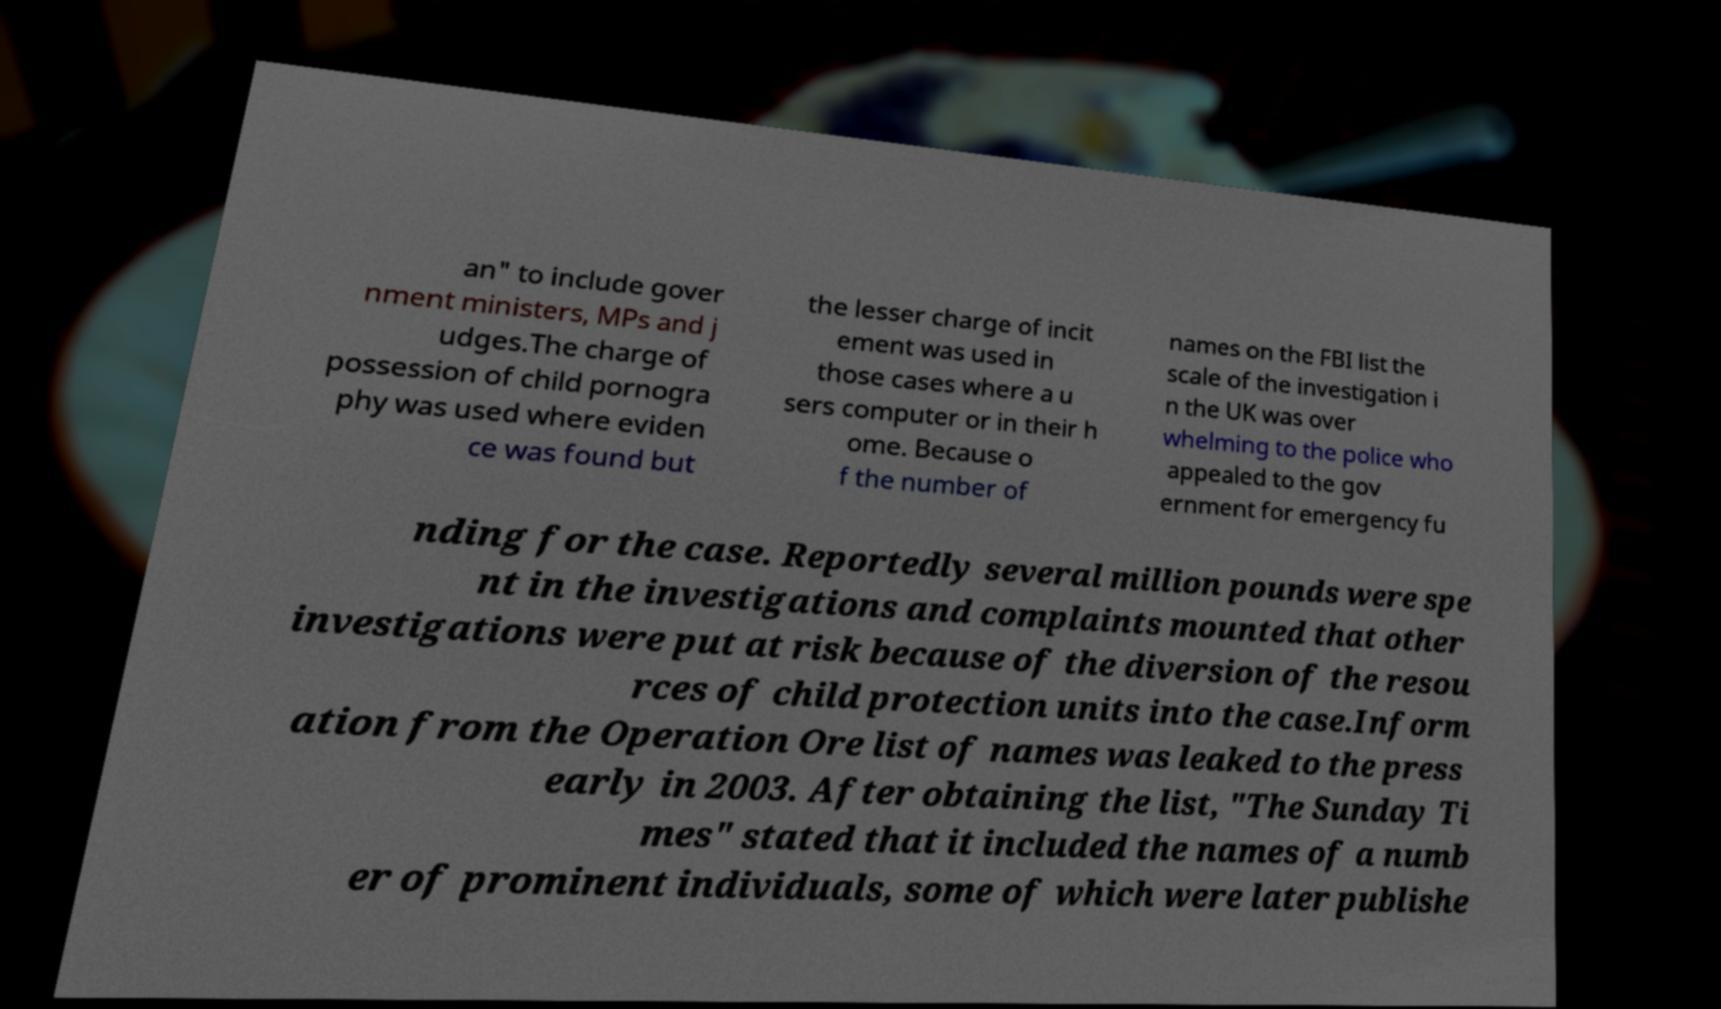What messages or text are displayed in this image? I need them in a readable, typed format. an" to include gover nment ministers, MPs and j udges.The charge of possession of child pornogra phy was used where eviden ce was found but the lesser charge of incit ement was used in those cases where a u sers computer or in their h ome. Because o f the number of names on the FBI list the scale of the investigation i n the UK was over whelming to the police who appealed to the gov ernment for emergency fu nding for the case. Reportedly several million pounds were spe nt in the investigations and complaints mounted that other investigations were put at risk because of the diversion of the resou rces of child protection units into the case.Inform ation from the Operation Ore list of names was leaked to the press early in 2003. After obtaining the list, "The Sunday Ti mes" stated that it included the names of a numb er of prominent individuals, some of which were later publishe 